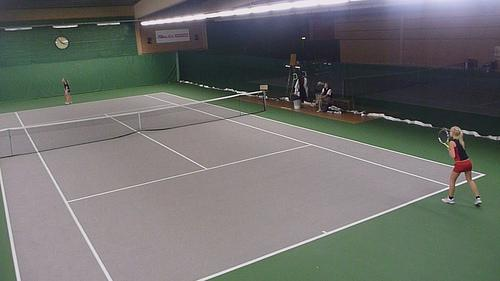State the main action occurring on the tennis court. A female tennis player in red shorts is holding a yellow and white racket while playing a match. Mention the hairstyle of the female tennis player and where she's standing. The female tennis player has blonde hair in a ponytail and stands at the near end of the grey and green court. What are some details about the spectators in the scene? A man is sitting down with crossed legs, observing the game, while other people are also watching the tennis match. Mention the prominent feature of the tennis court and the color of the back wall. The tennis court has a gray and green surface with a green back wall behind. Write about the object on the ceiling and one other object on the court. Lights hanging on the ceiling illuminate the court, where a white and black clock is visible on the wall. Detail the objects hanging on the wall and a notable feature of the part of the tennis court. A clock and a sign are hanging on the wall, and there is a green out-of-bounds part on the tennis court. What type of clock is in the image and where is it located? A white and black clock is hanging on the wall of the tennis court. What is the color and placement of the tennis net? The tennis net has black and white colors and spans across the width of the tennis court. Describe the appearance and position of the woman playing tennis. A blonde woman wearing red shorts and white shoes is at one end of the court, in the middle of a tennis match. Use one sentence to describe the main subjects in the scene. A woman in red shorts holding a racket competes on the tennis court while a man watches her attentively. 